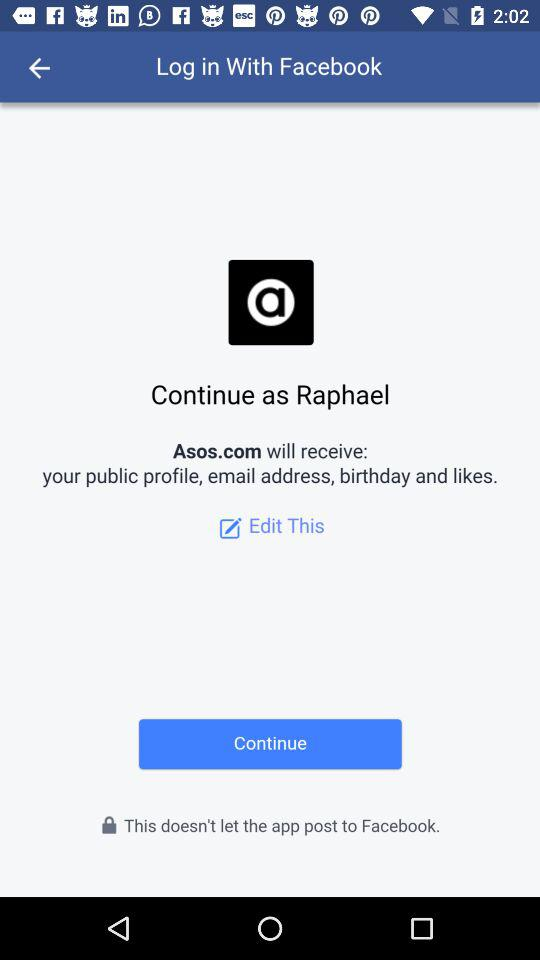What applications can we log in with? You can log in with "Facebook". 